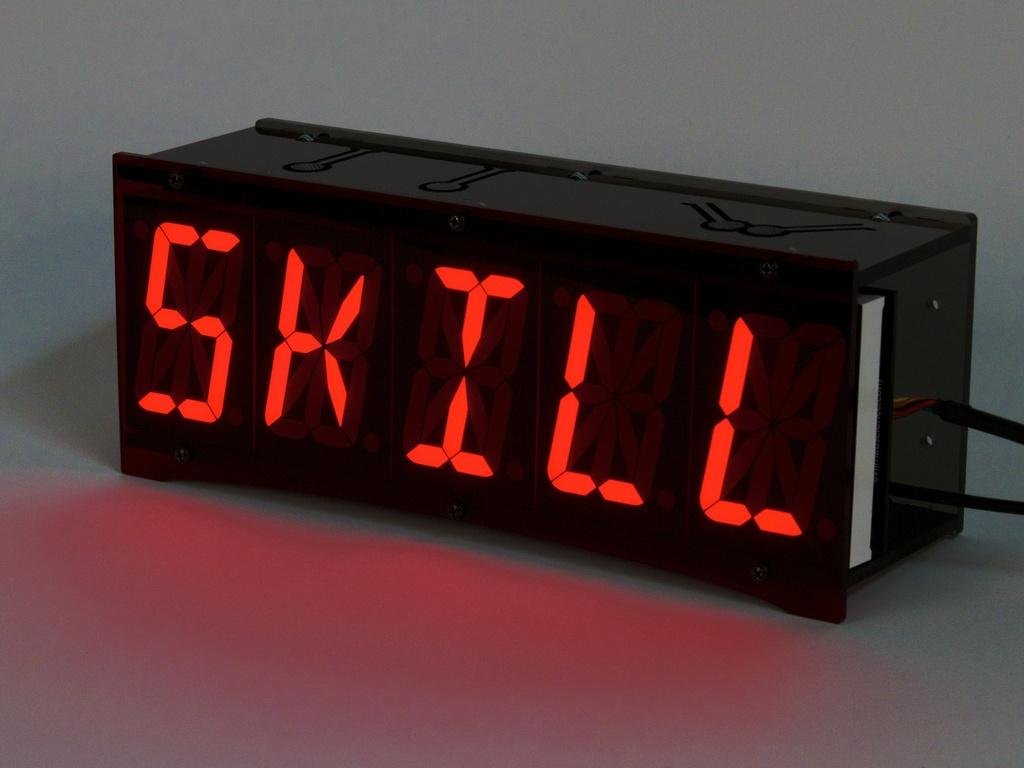<image>
Offer a succinct explanation of the picture presented. a digital read out in red that says SKILL 